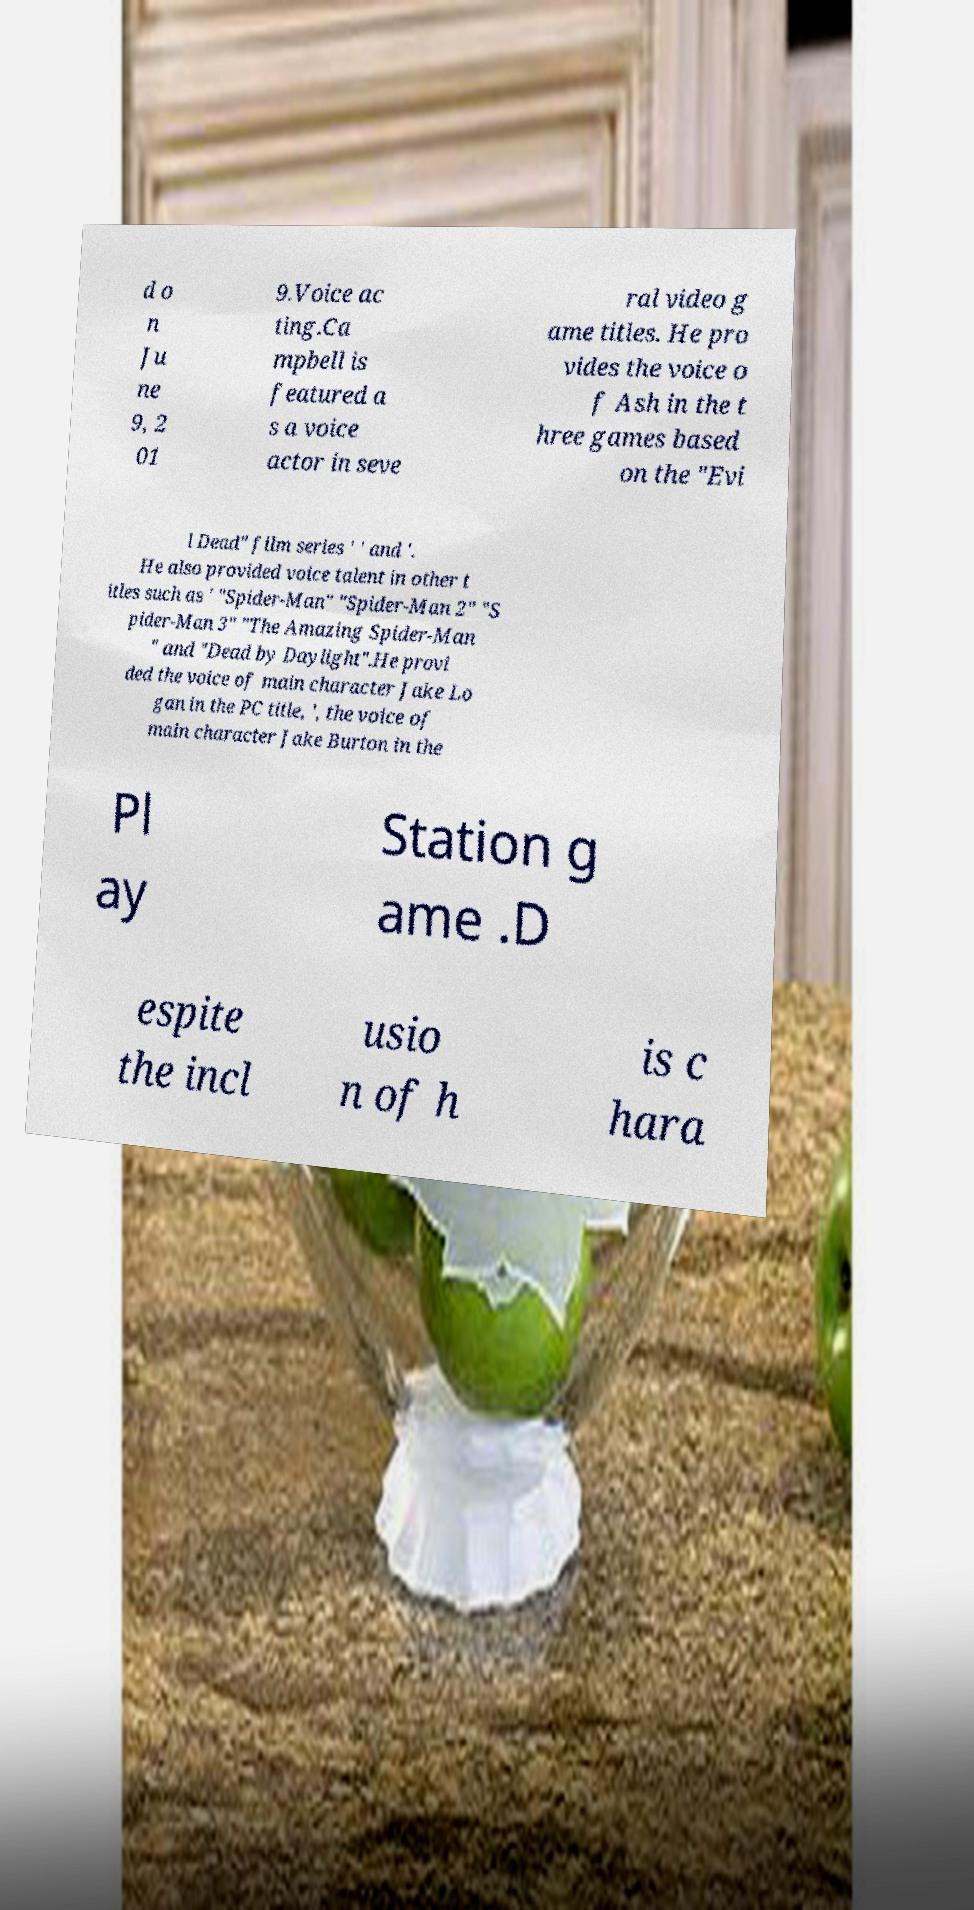Can you read and provide the text displayed in the image?This photo seems to have some interesting text. Can you extract and type it out for me? d o n Ju ne 9, 2 01 9.Voice ac ting.Ca mpbell is featured a s a voice actor in seve ral video g ame titles. He pro vides the voice o f Ash in the t hree games based on the "Evi l Dead" film series ' ' and '. He also provided voice talent in other t itles such as ' "Spider-Man" "Spider-Man 2" "S pider-Man 3" "The Amazing Spider-Man " and "Dead by Daylight".He provi ded the voice of main character Jake Lo gan in the PC title, ', the voice of main character Jake Burton in the Pl ay Station g ame .D espite the incl usio n of h is c hara 